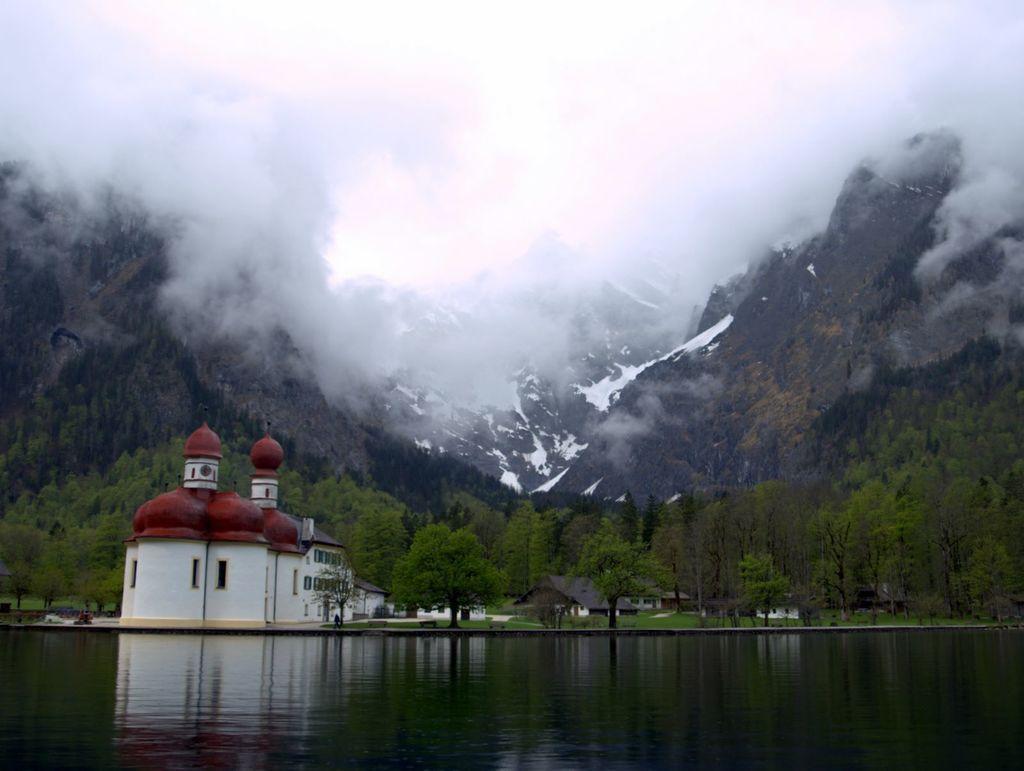Please provide a concise description of this image. In this image we can see some buildings and houses with roof near a water body. We can also see a group of trees, the hills and the sky which looks cloudy. 